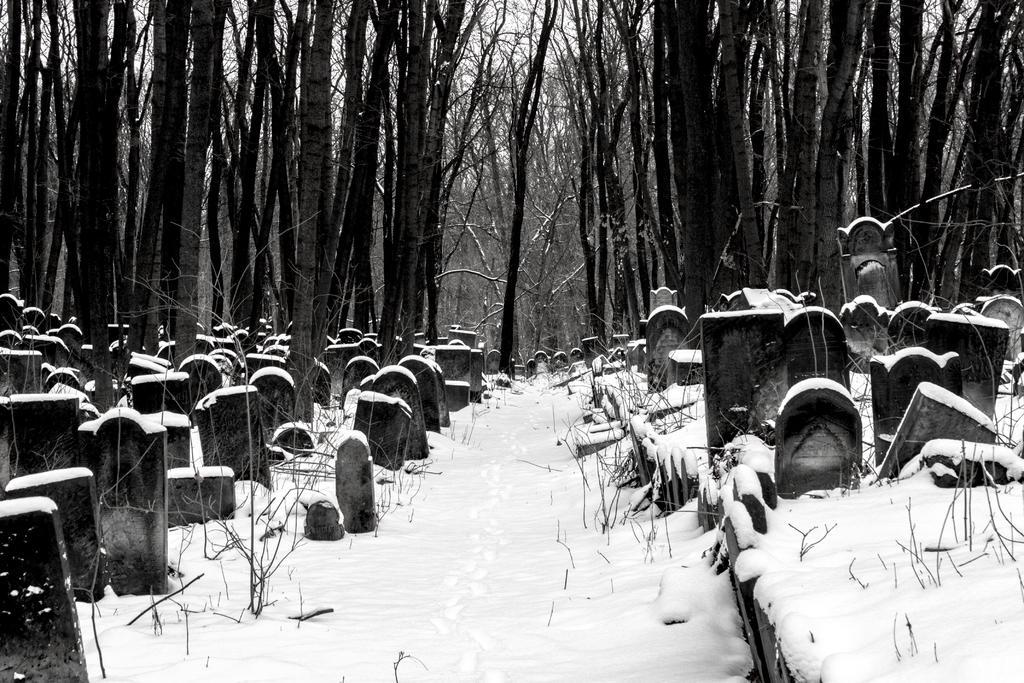Can you describe this image briefly? This is a black and white image. In this image we can see a group of grave stones, some plants, snow, a group of trees and the sky which looks cloudy. 